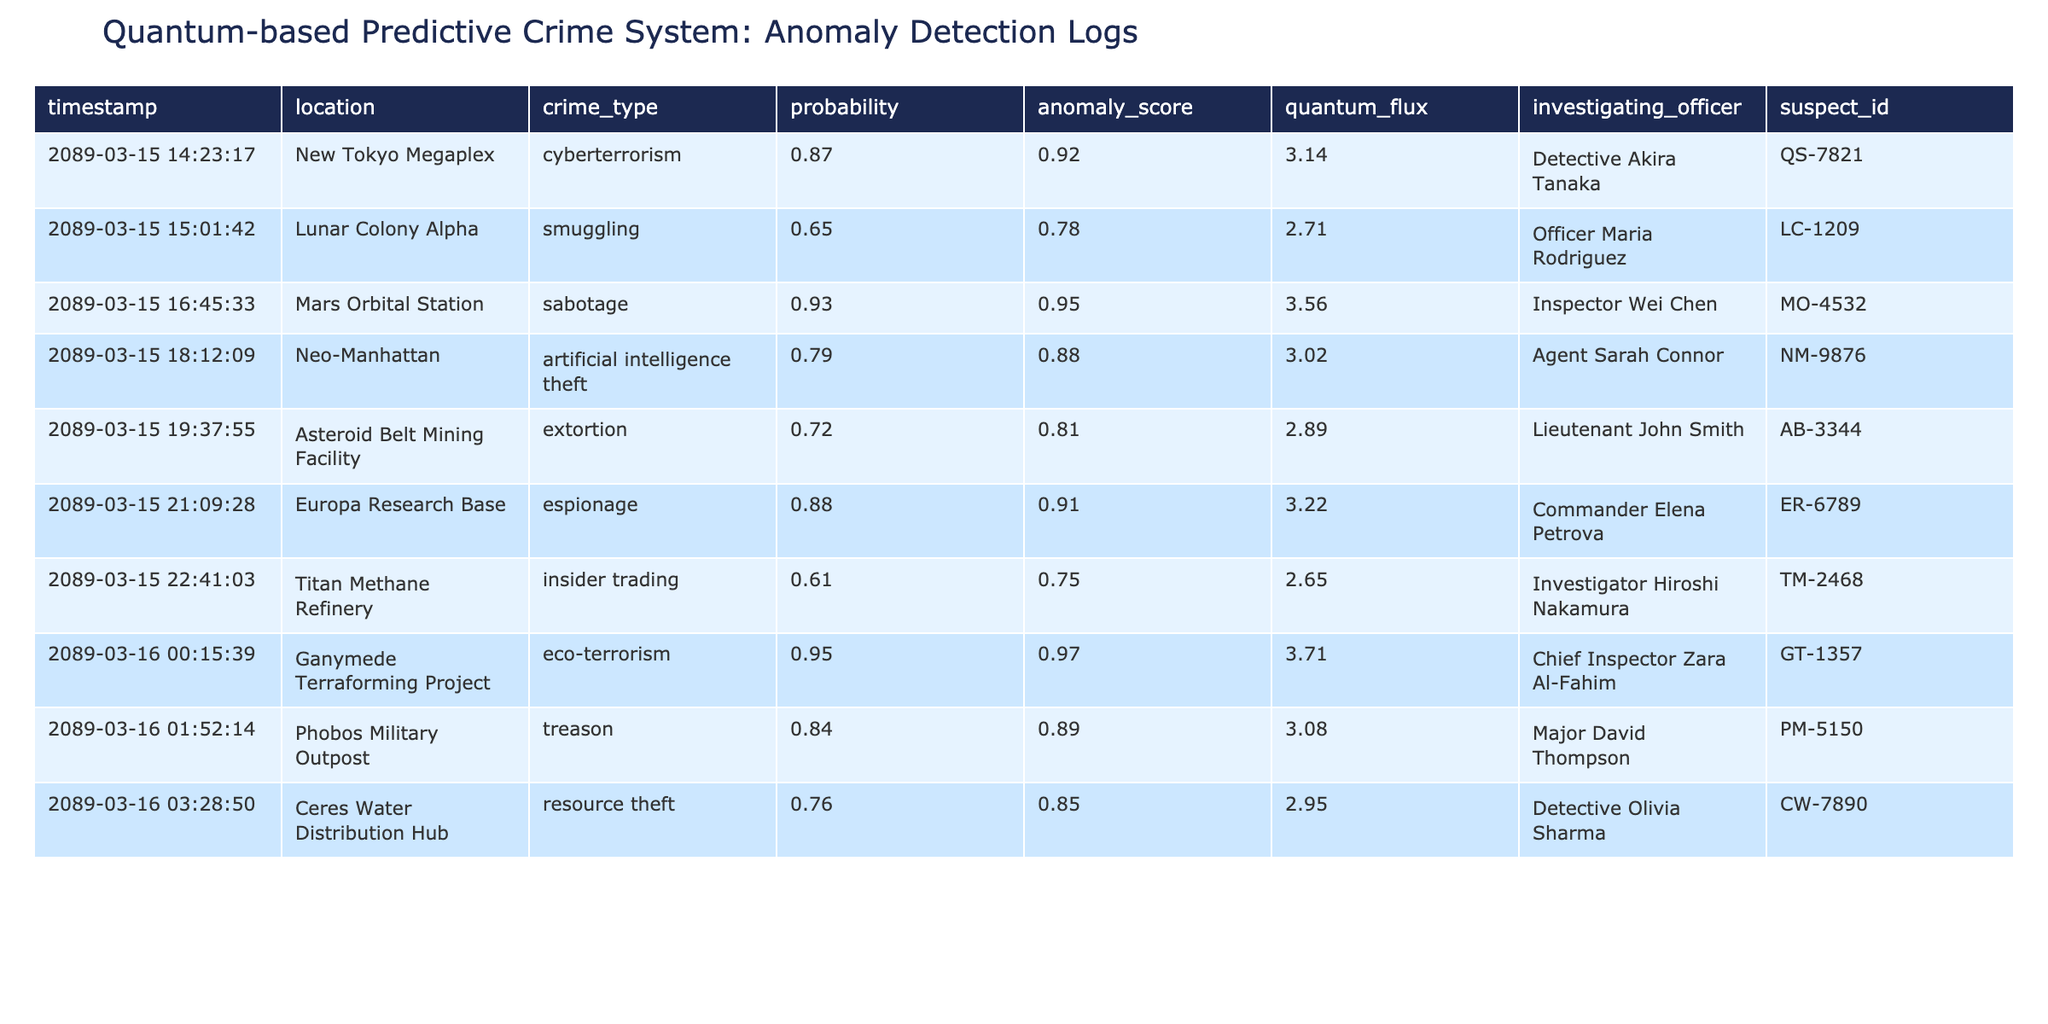What is the highest anomaly score recorded in the logs? Looking at the "anomaly_score" column, the highest value is 0.97, which corresponds to the entry for eco-terrorism at the Ganymede Terraforming Project.
Answer: 0.97 Which crime type has the lowest probability of occurring? In the "probability" column, the lowest value is 0.61 for the crime type "insider trading" at the Titan Methane Refinery.
Answer: insider trading How many different crime types are documented in the logs? The unique entries in the "crime_type" column are: cyberterrorism, smuggling, sabotage, artificial intelligence theft, extortion, espionage, insider trading, eco-terrorism, treason, and resource theft. There are 10 unique crime types.
Answer: 10 Are there any crimes with a probability of 0.9 or higher? Yes, the probability of 0.9 or higher is noted for three crimes: cyberterrorism (0.87), sabotage (0.93), and eco-terrorism (0.95). Thus, there are instances meeting this criterion.
Answer: Yes What is the average quantum flux for all entries in the logs? Adding the quantum flux values (3.14 + 2.71 + 3.56 + 3.02 + 2.89 + 3.22 + 2.65 + 3.71 + 3.08 + 2.95) gives a total of 31.00. Since there are 10 entries, the average is 31.00/10 = 3.10.
Answer: 3.10 Which officer is assigned to investigate the highest anomaly score case? The highest anomaly score is 0.97, related to eco-terrorism, which is assigned to Chief Inspector Zara Al-Fahim.
Answer: Chief Inspector Zara Al-Fahim Is there any crime associated with the suspect ID "LC-1209"? Yes, "LC-1209" is associated with the crime type "smuggling" at Lunar Colony Alpha, which has a probability of 0.65.
Answer: Yes How many crimes have a probability less than 0.7? Upon reviewing the "probability" column, the crimes with a probability less than 0.7 are insider trading (0.61) and smuggling (0.65). This totals to 2 crimes.
Answer: 2 What is the total number of investigating officers listed in the logs? The "investigating_officer" column lists unique officers, totaling 10 different investigating officers overseeing various cases.
Answer: 10 How does the anomaly score for espionage compare to resource theft? The anomaly score for espionage is 0.91 and for resource theft it is 0.85. 0.91 is greater than 0.85, indicating espionage presents a higher risk.
Answer: Espionage has a higher anomaly score than resource theft Which location has the highest probability for crime? The location with the highest probability is the Mars Orbital Station with a probability of 0.93 for sabotage.
Answer: Mars Orbital Station 